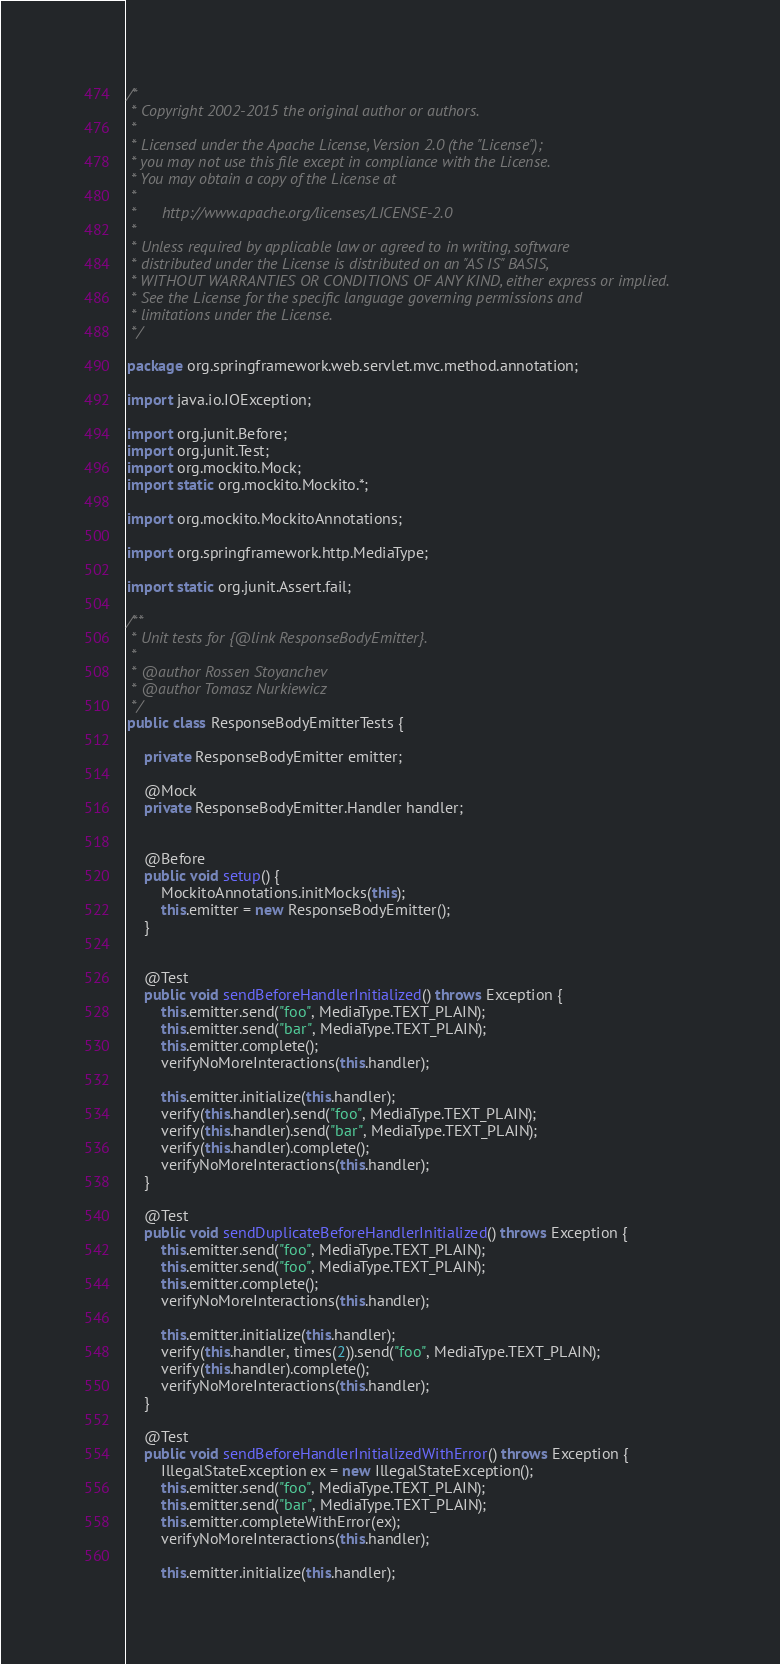<code> <loc_0><loc_0><loc_500><loc_500><_Java_>/*
 * Copyright 2002-2015 the original author or authors.
 *
 * Licensed under the Apache License, Version 2.0 (the "License");
 * you may not use this file except in compliance with the License.
 * You may obtain a copy of the License at
 *
 *      http://www.apache.org/licenses/LICENSE-2.0
 *
 * Unless required by applicable law or agreed to in writing, software
 * distributed under the License is distributed on an "AS IS" BASIS,
 * WITHOUT WARRANTIES OR CONDITIONS OF ANY KIND, either express or implied.
 * See the License for the specific language governing permissions and
 * limitations under the License.
 */

package org.springframework.web.servlet.mvc.method.annotation;

import java.io.IOException;

import org.junit.Before;
import org.junit.Test;
import org.mockito.Mock;
import static org.mockito.Mockito.*;

import org.mockito.MockitoAnnotations;

import org.springframework.http.MediaType;

import static org.junit.Assert.fail;

/**
 * Unit tests for {@link ResponseBodyEmitter}.
 *
 * @author Rossen Stoyanchev
 * @author Tomasz Nurkiewicz
 */
public class ResponseBodyEmitterTests {

	private ResponseBodyEmitter emitter;

	@Mock
	private ResponseBodyEmitter.Handler handler;


	@Before
	public void setup() {
		MockitoAnnotations.initMocks(this);
		this.emitter = new ResponseBodyEmitter();
	}


	@Test
	public void sendBeforeHandlerInitialized() throws Exception {
		this.emitter.send("foo", MediaType.TEXT_PLAIN);
		this.emitter.send("bar", MediaType.TEXT_PLAIN);
		this.emitter.complete();
		verifyNoMoreInteractions(this.handler);

		this.emitter.initialize(this.handler);
		verify(this.handler).send("foo", MediaType.TEXT_PLAIN);
		verify(this.handler).send("bar", MediaType.TEXT_PLAIN);
		verify(this.handler).complete();
		verifyNoMoreInteractions(this.handler);
	}

	@Test
	public void sendDuplicateBeforeHandlerInitialized() throws Exception {
		this.emitter.send("foo", MediaType.TEXT_PLAIN);
		this.emitter.send("foo", MediaType.TEXT_PLAIN);
		this.emitter.complete();
		verifyNoMoreInteractions(this.handler);

		this.emitter.initialize(this.handler);
		verify(this.handler, times(2)).send("foo", MediaType.TEXT_PLAIN);
		verify(this.handler).complete();
		verifyNoMoreInteractions(this.handler);
	}

	@Test
	public void sendBeforeHandlerInitializedWithError() throws Exception {
		IllegalStateException ex = new IllegalStateException();
		this.emitter.send("foo", MediaType.TEXT_PLAIN);
		this.emitter.send("bar", MediaType.TEXT_PLAIN);
		this.emitter.completeWithError(ex);
		verifyNoMoreInteractions(this.handler);

		this.emitter.initialize(this.handler);</code> 